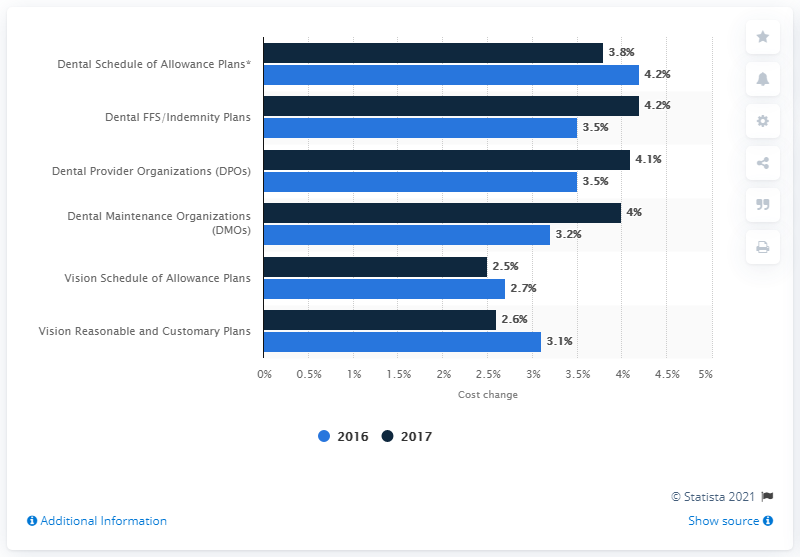List a handful of essential elements in this visual. According to a survey of health insurers, it is expected that the cost of dental services for Dental Service Organizations (DPOs) will increase by 3.8% in 2017. 